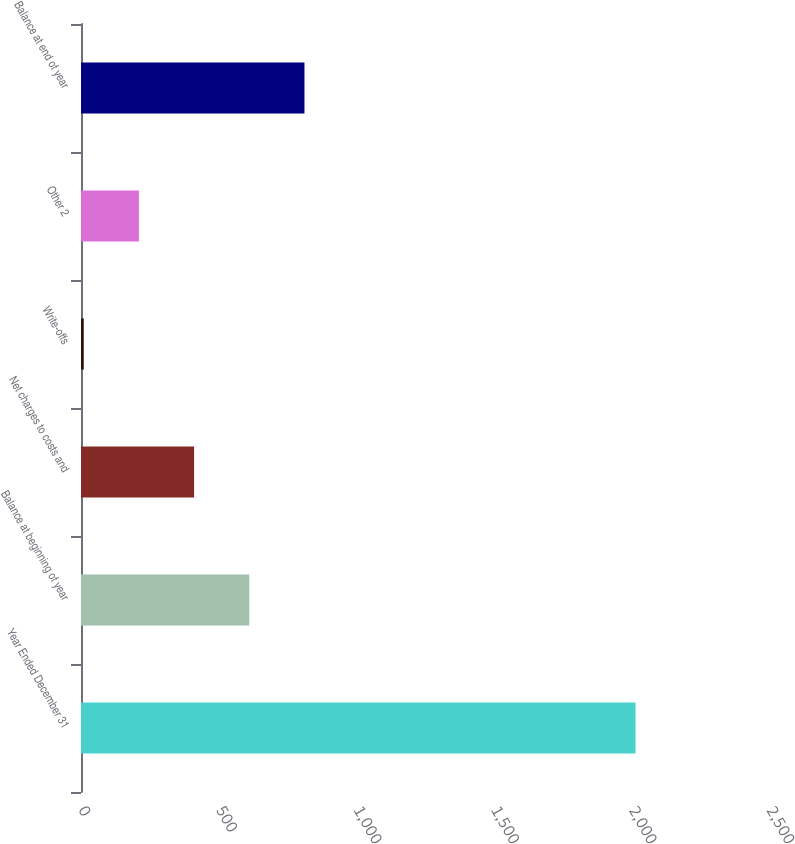Convert chart to OTSL. <chart><loc_0><loc_0><loc_500><loc_500><bar_chart><fcel>Year Ended December 31<fcel>Balance at beginning of year<fcel>Net charges to costs and<fcel>Write-offs<fcel>Other 2<fcel>Balance at end of year<nl><fcel>2015<fcel>611.5<fcel>411<fcel>10<fcel>210.5<fcel>812<nl></chart> 